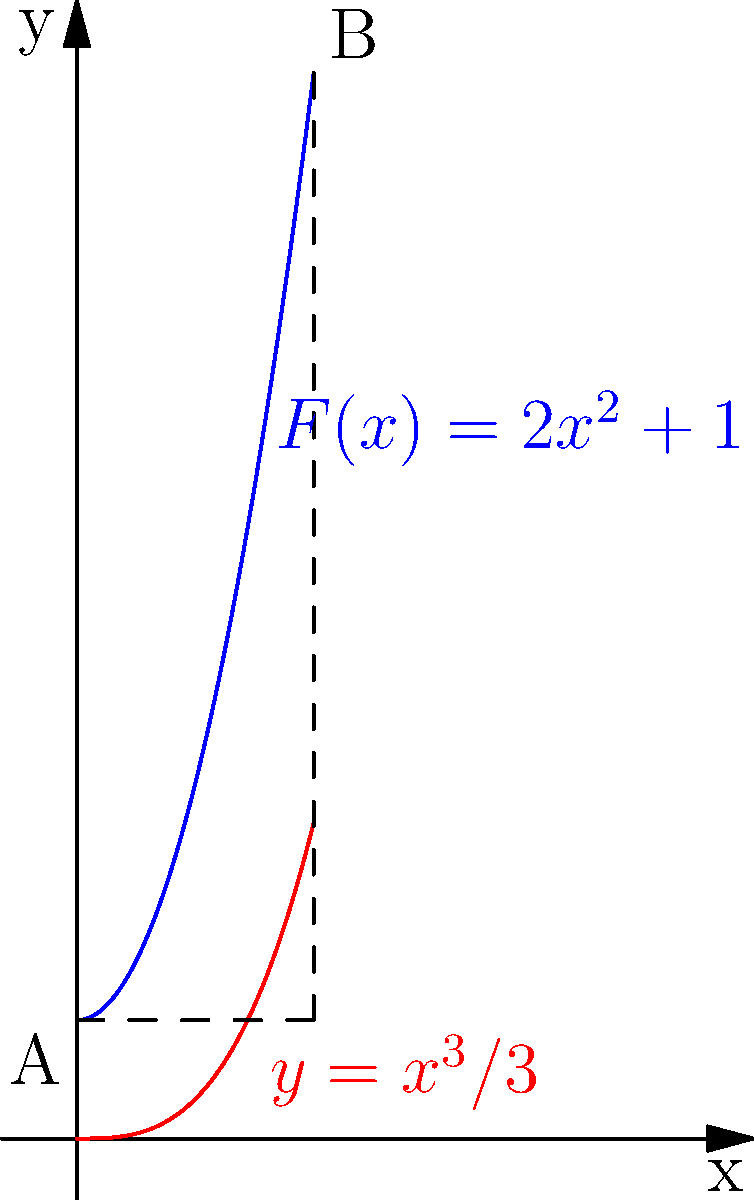Рассмотрите криволинейный путь, заданный функцией $y = \frac{x^3}{3}$ от точки $A(0,1)$ до точки $B(2,9)$. Переменная сила $F(x) = 2x^2 + 1$ действует вдоль этого пути. Вычислите работу, совершенную силой $F(x)$ вдоль этого пути, используя интегрирование. Представьте ответ с точностью до двух знаков после запятой. Для решения этой задачи выполним следующие шаги:

1) Работа, совершаемая переменной силой вдоль криволинейного пути, вычисляется по формуле:
   $$W = \int_a^b F(x) \cdot \frac{dy}{dx} dx$$

2) У нас есть:
   $F(x) = 2x^2 + 1$
   $y = \frac{x^3}{3}$

3) Найдем $\frac{dy}{dx}$:
   $$\frac{dy}{dx} = x^2$$

4) Подставим в формулу работы:
   $$W = \int_0^2 (2x^2 + 1) \cdot x^2 dx$$

5) Раскроем скобки:
   $$W = \int_0^2 (2x^4 + x^2) dx$$

6) Проинтегрируем:
   $$W = [\frac{2x^5}{5} + \frac{x^3}{3}]_0^2$$

7) Вычислим значения на границах интервала:
   $$W = (\frac{2 \cdot 2^5}{5} + \frac{2^3}{3}) - (0 + 0)$$

8) Упростим:
   $$W = \frac{64}{5} + \frac{8}{3} = 12.8 + 2.67 = 15.47$$

9) Округлим до двух знаков после запятой:
   $$W \approx 15.47$$
Answer: 15.47 Дж 